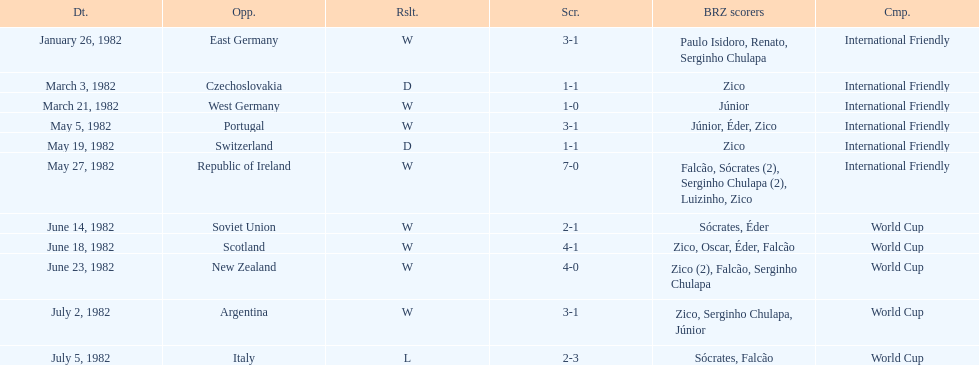What are the dates January 26, 1982, March 3, 1982, March 21, 1982, May 5, 1982, May 19, 1982, May 27, 1982, June 14, 1982, June 18, 1982, June 23, 1982, July 2, 1982, July 5, 1982. Which date is at the top? January 26, 1982. 